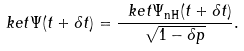<formula> <loc_0><loc_0><loc_500><loc_500>\ k e t { \Psi ( t + \delta t ) } = \frac { \ k e t { \Psi _ { \text {nH} } ( t + \delta t ) } } { \sqrt { 1 - \delta p } } .</formula> 